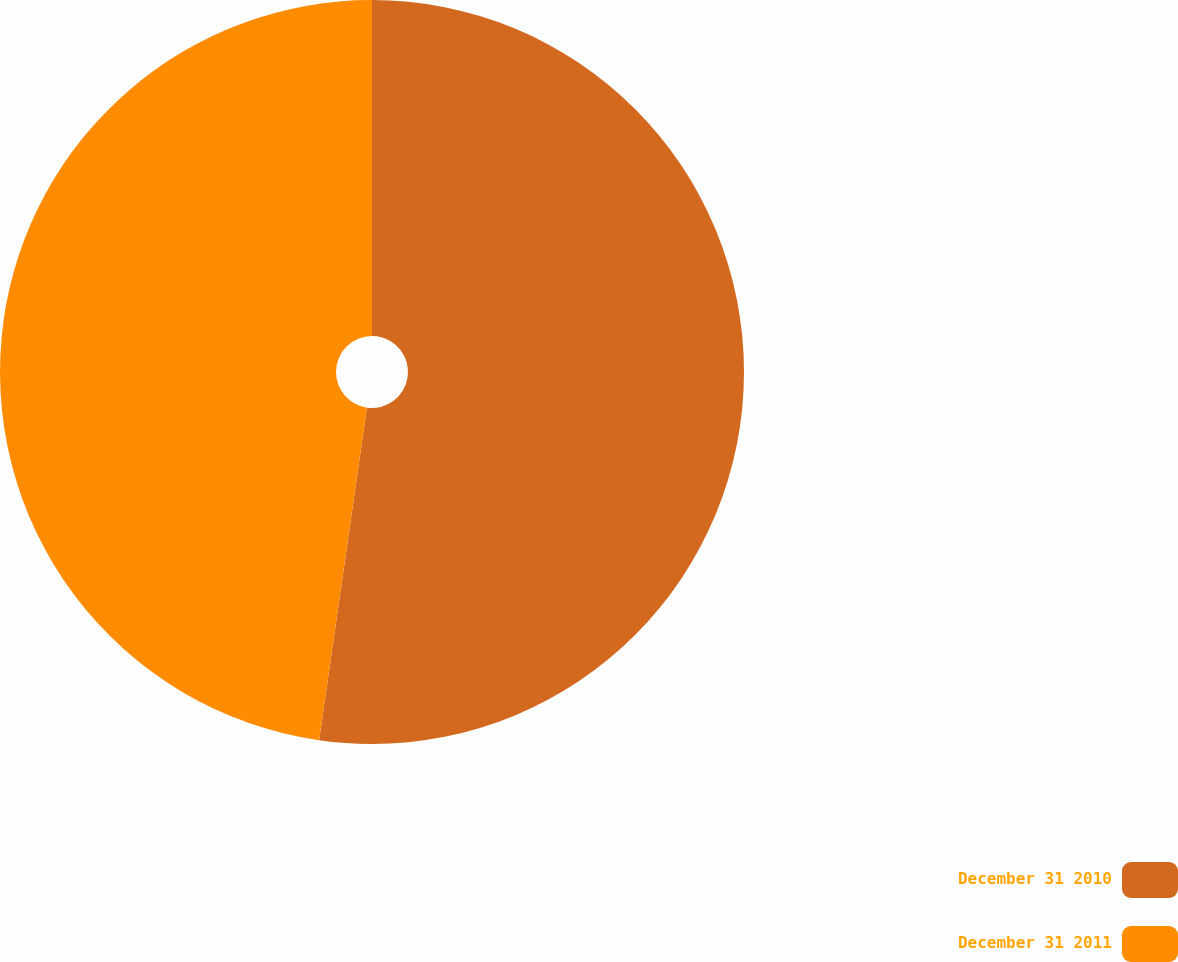<chart> <loc_0><loc_0><loc_500><loc_500><pie_chart><fcel>December 31 2010<fcel>December 31 2011<nl><fcel>52.27%<fcel>47.73%<nl></chart> 